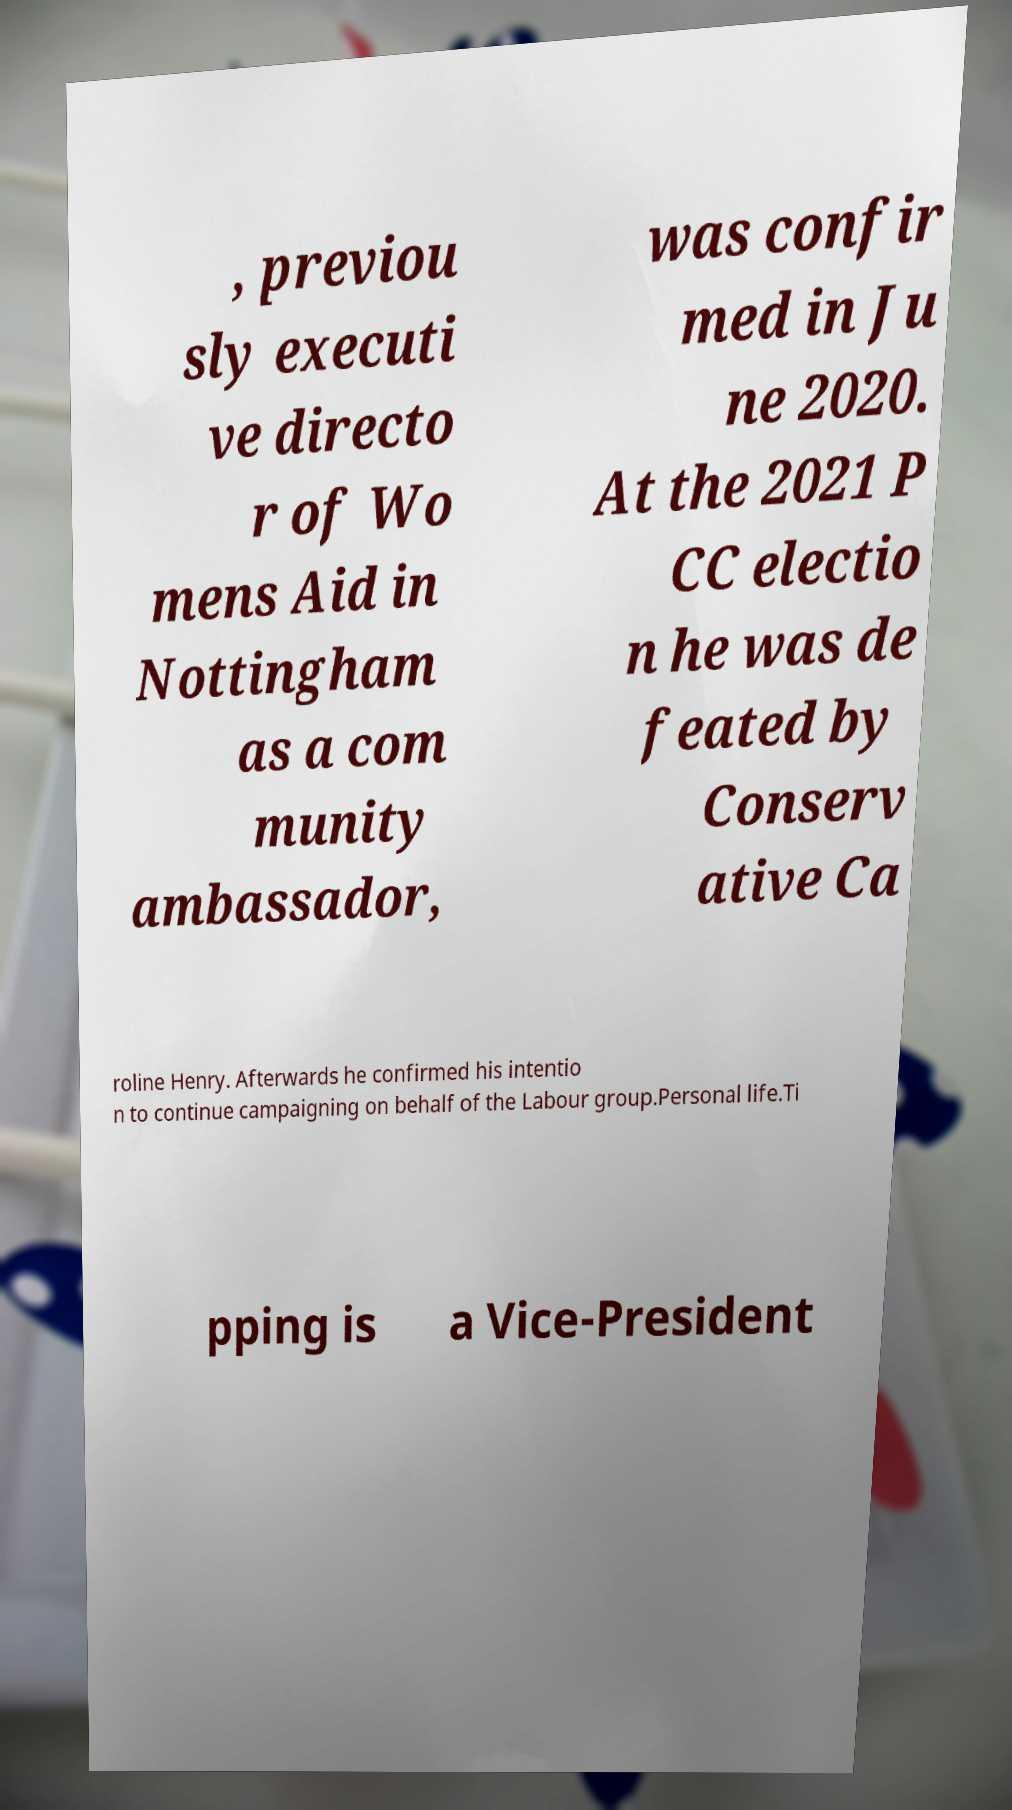There's text embedded in this image that I need extracted. Can you transcribe it verbatim? , previou sly executi ve directo r of Wo mens Aid in Nottingham as a com munity ambassador, was confir med in Ju ne 2020. At the 2021 P CC electio n he was de feated by Conserv ative Ca roline Henry. Afterwards he confirmed his intentio n to continue campaigning on behalf of the Labour group.Personal life.Ti pping is a Vice-President 